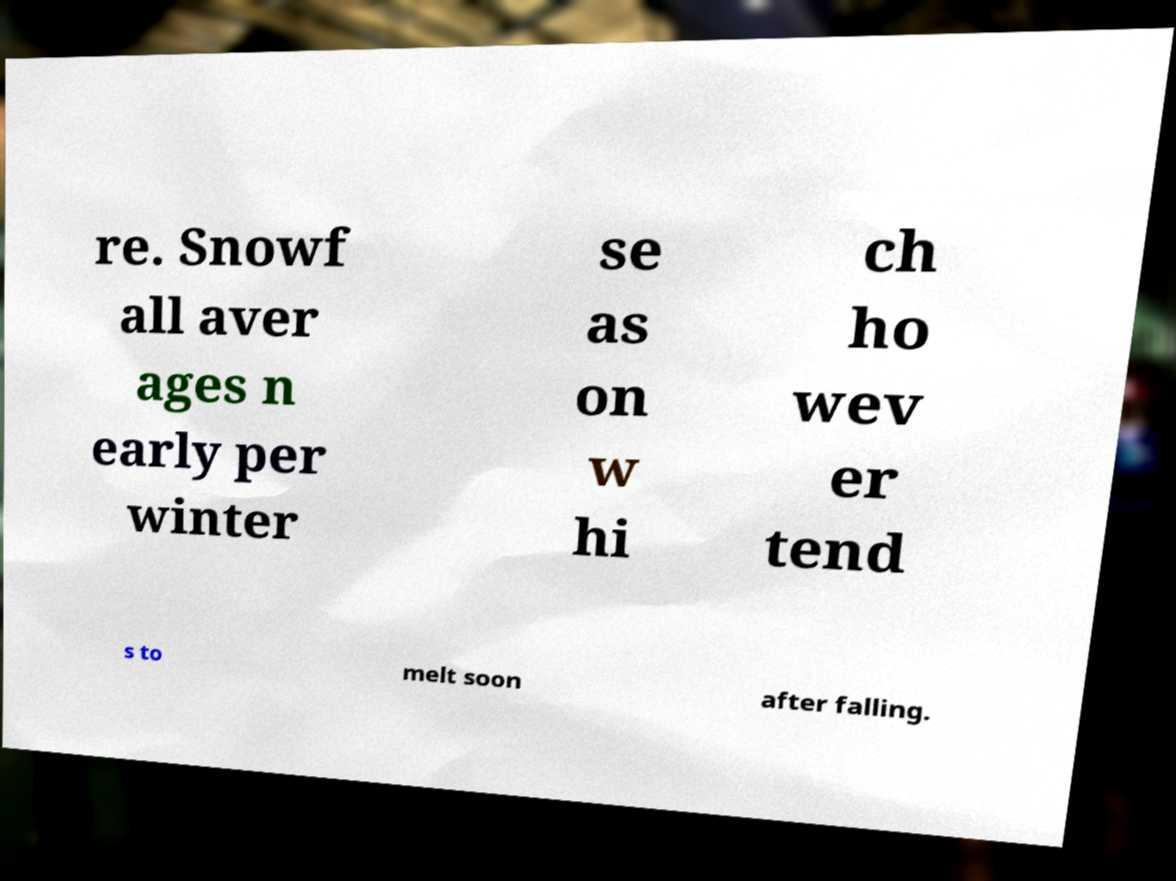Could you assist in decoding the text presented in this image and type it out clearly? re. Snowf all aver ages n early per winter se as on w hi ch ho wev er tend s to melt soon after falling. 